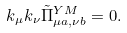Convert formula to latex. <formula><loc_0><loc_0><loc_500><loc_500>k _ { \mu } k _ { \nu } \tilde { \Pi } ^ { Y M } _ { \mu a , \nu b } = 0 .</formula> 